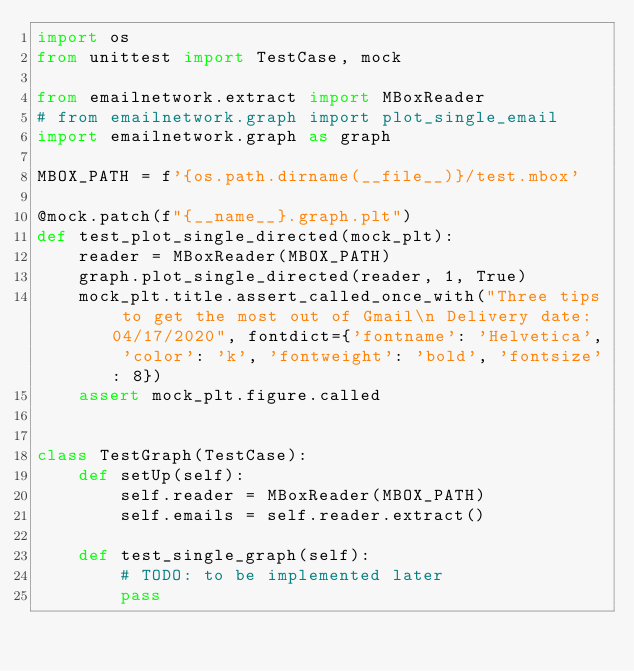<code> <loc_0><loc_0><loc_500><loc_500><_Python_>import os
from unittest import TestCase, mock

from emailnetwork.extract import MBoxReader
# from emailnetwork.graph import plot_single_email
import emailnetwork.graph as graph

MBOX_PATH = f'{os.path.dirname(__file__)}/test.mbox'

@mock.patch(f"{__name__}.graph.plt")
def test_plot_single_directed(mock_plt):
    reader = MBoxReader(MBOX_PATH)
    graph.plot_single_directed(reader, 1, True)
    mock_plt.title.assert_called_once_with("Three tips to get the most out of Gmail\n Delivery date: 04/17/2020", fontdict={'fontname': 'Helvetica', 'color': 'k', 'fontweight': 'bold', 'fontsize': 8})
    assert mock_plt.figure.called


class TestGraph(TestCase):
    def setUp(self):
        self.reader = MBoxReader(MBOX_PATH)
        self.emails = self.reader.extract()

    def test_single_graph(self):
        # TODO: to be implemented later
        pass
        
</code> 